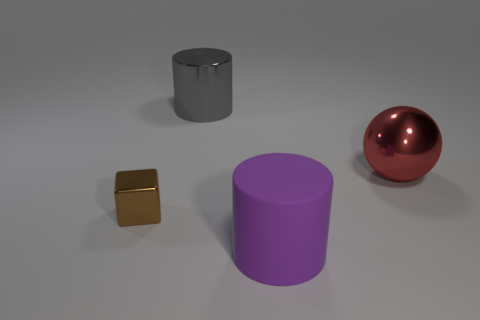Add 4 large yellow matte cylinders. How many objects exist? 8 Subtract all cubes. How many objects are left? 3 Subtract all small cubes. Subtract all metal cubes. How many objects are left? 2 Add 1 purple objects. How many purple objects are left? 2 Add 2 tiny brown blocks. How many tiny brown blocks exist? 3 Subtract 0 green balls. How many objects are left? 4 